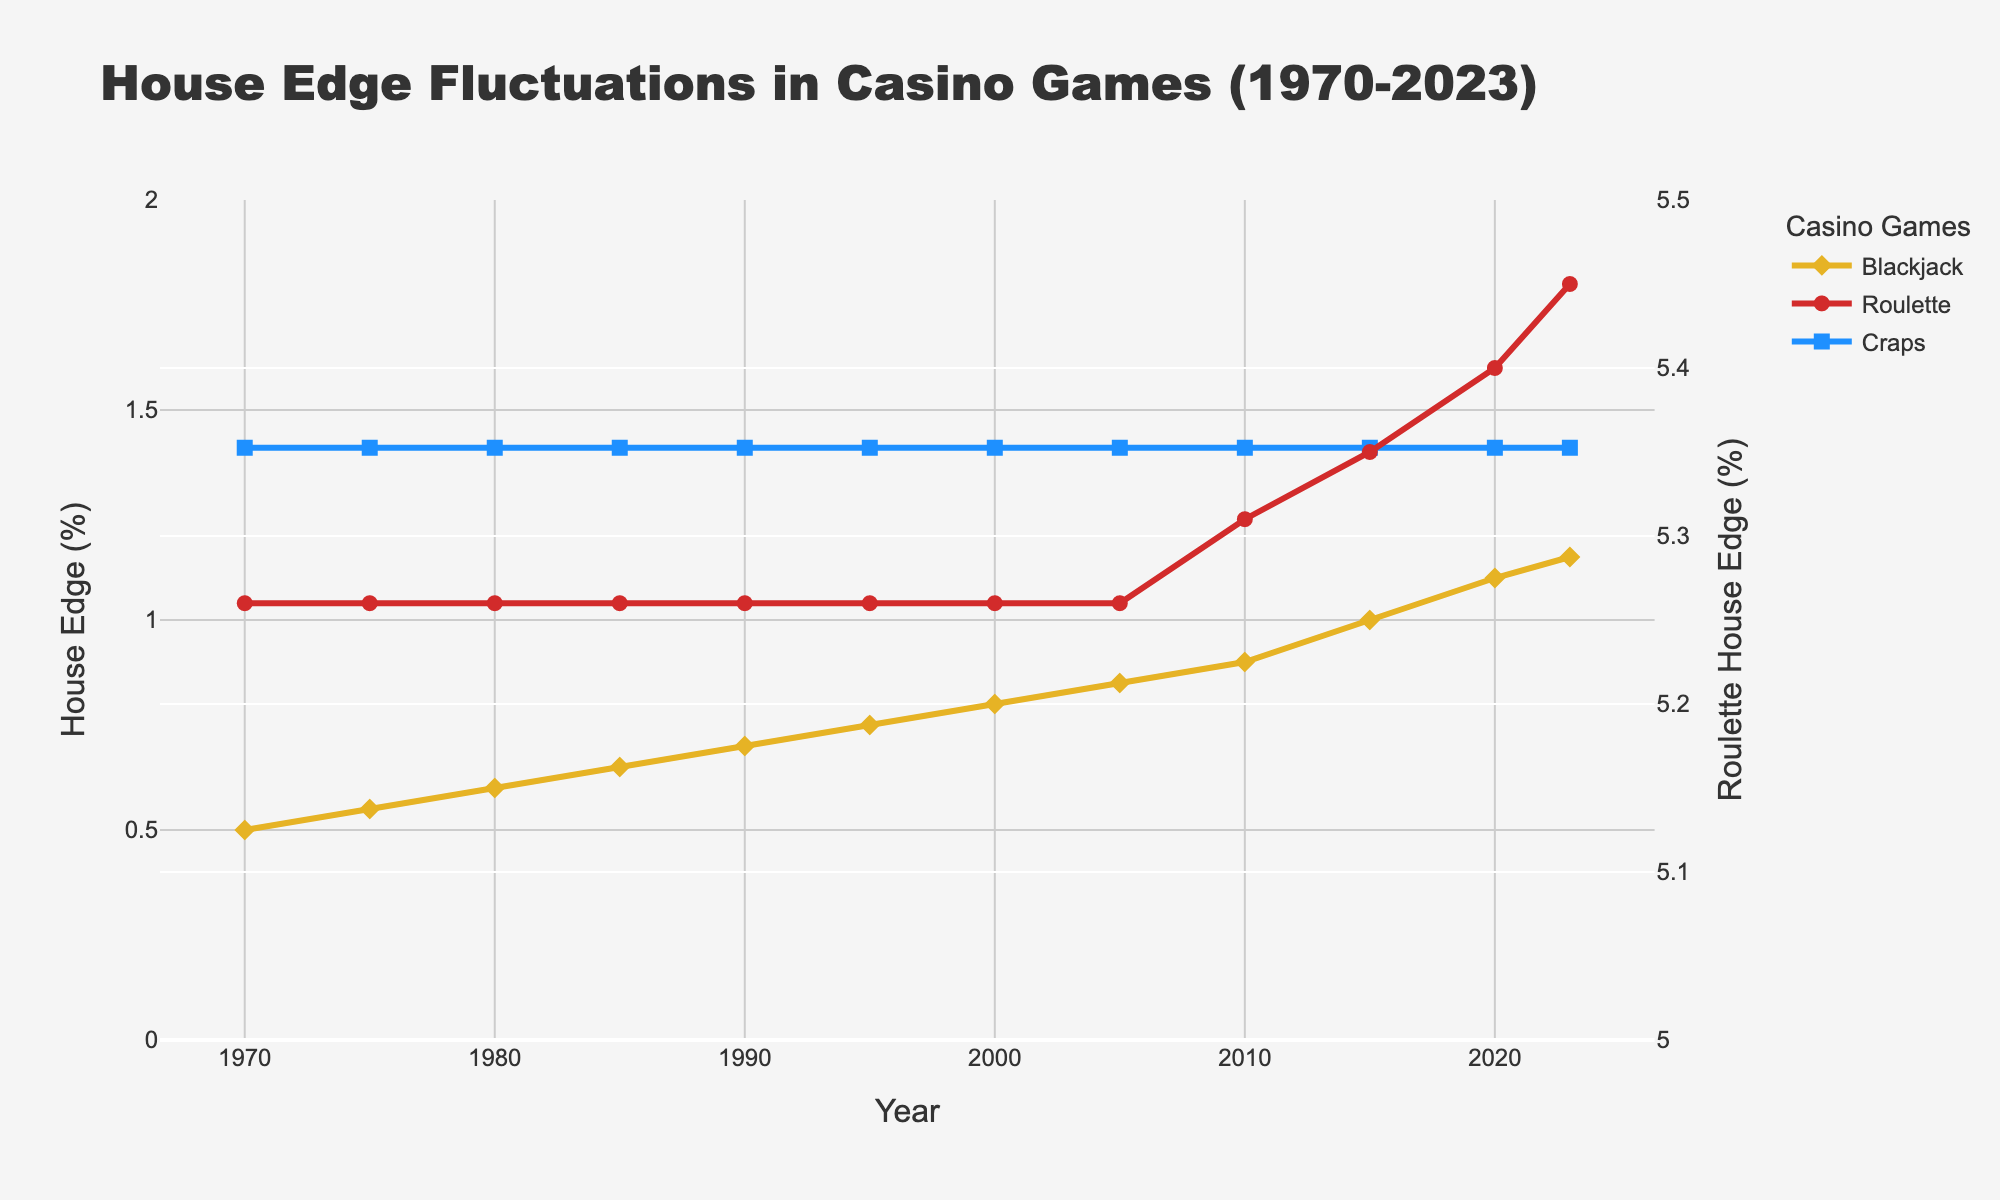What game experienced the highest increase in the house edge from 1970 to 2023? First, identify the house edge for each game in 1970 and 2023. For Blackjack, it increased from 0.50% to 1.15%. For Roulette, it increased from 5.26% to 5.45%. For Craps, it stayed constant at 1.41%. Calculation shows that Blackjack experienced the highest increase of 0.65%.
Answer: Blackjack How did the house edge for Roulette change over time? Look at the data points for Roulette over the years. From 1970 to 2005, the house edge was constant at 5.26%. From 2010, it started to increase, reaching 5.45% by 2023.
Answer: It increased from 2010 to 2023 Which year saw the Blackjack house edge reach 1%? Check the data points for Blackjack over the years. The house edge reached 1% in 2015.
Answer: 2015 By how much did the house edge for Blackjack increase from 1990 to 2000? Look at the house edge for Blackjack in 1990 (0.70%) and in 2000 (0.80%). Subtract the 1990 value from the 2000 value, which gives 0.80% - 0.70% = 0.10%.
Answer: 0.10% Which game has the lowest house edge in 2023? Check the house edge for all three games in 2023: Blackjack (1.15%), Roulette (5.45%), and Craps (1.41%). The lowest house edge is for Craps.
Answer: Craps Compare the house edge of Blackjack and Craps in 1980. Which one was higher? Check the house edge for both Blackjack (0.60%) and Craps (1.41%) in 1980. Craps had the higher house edge.
Answer: Craps How does the house edge for Roulette in 2010 compare to that of Blackjack in 2020? The house edge for Roulette in 2010 is 5.31%, and for Blackjack in 2020, it's 1.10%. Roulette's house edge in 2010 is higher.
Answer: Roulette's edge is higher What's the average house edge for Craps from 1970 to 2023? Sum up the house edge for Craps over all the years provided and divide by the number of years. The house edge doesn't change and stays constant at 1.41%. Thus, the average is 1.41%.
Answer: 1.41% By how much did the house edge for Roulette increase from 2010 to 2023? The house edge for Roulette in 2010 was 5.31%, and in 2023 it was 5.45%. The increase is 5.45% - 5.31% = 0.14%.
Answer: 0.14% 